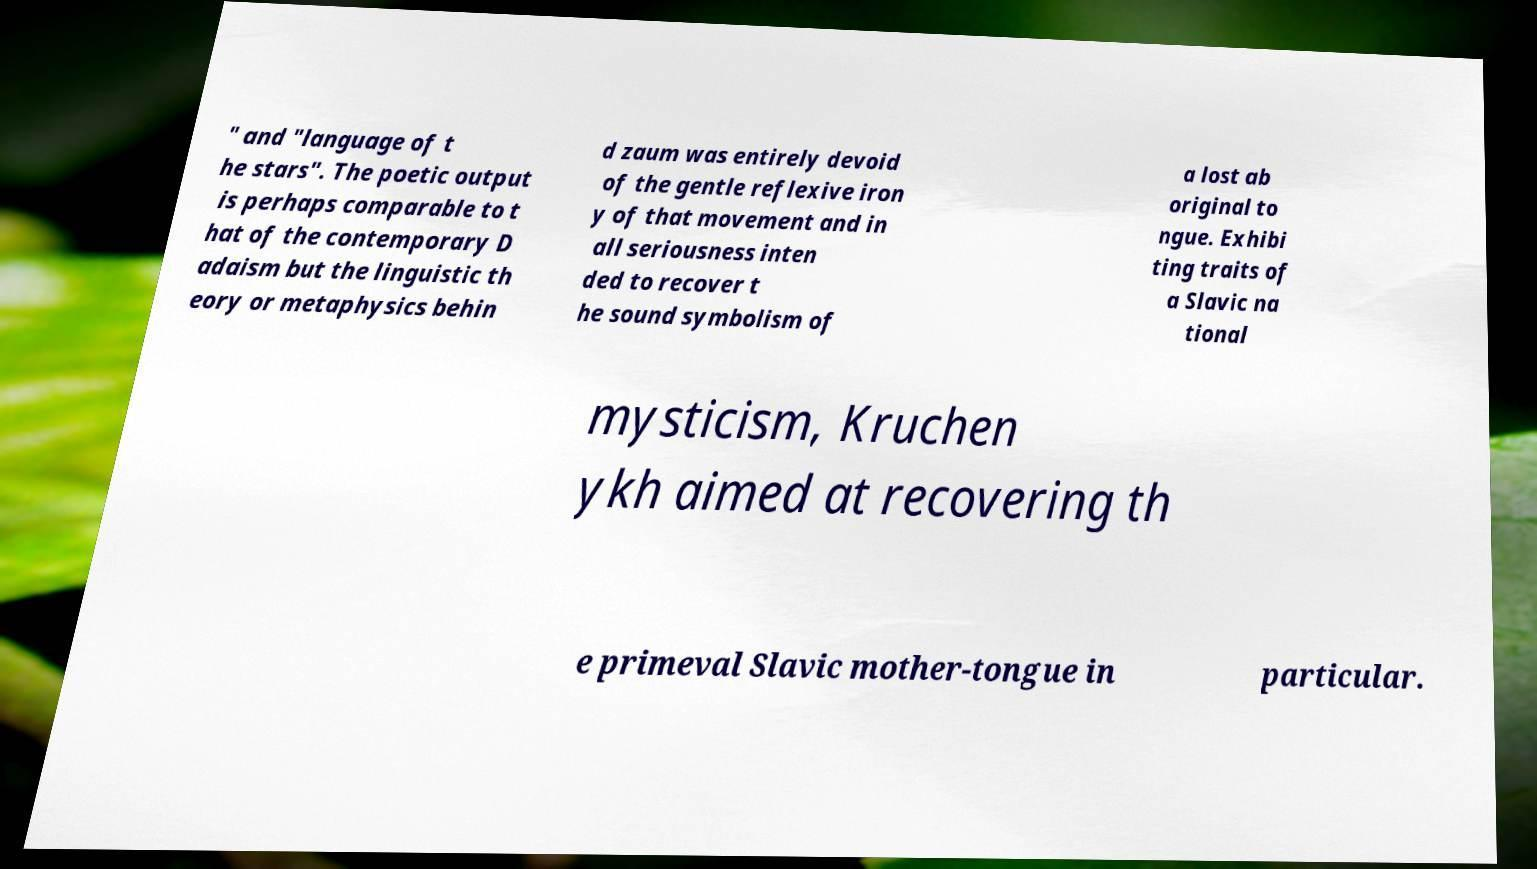For documentation purposes, I need the text within this image transcribed. Could you provide that? " and "language of t he stars". The poetic output is perhaps comparable to t hat of the contemporary D adaism but the linguistic th eory or metaphysics behin d zaum was entirely devoid of the gentle reflexive iron y of that movement and in all seriousness inten ded to recover t he sound symbolism of a lost ab original to ngue. Exhibi ting traits of a Slavic na tional mysticism, Kruchen ykh aimed at recovering th e primeval Slavic mother-tongue in particular. 